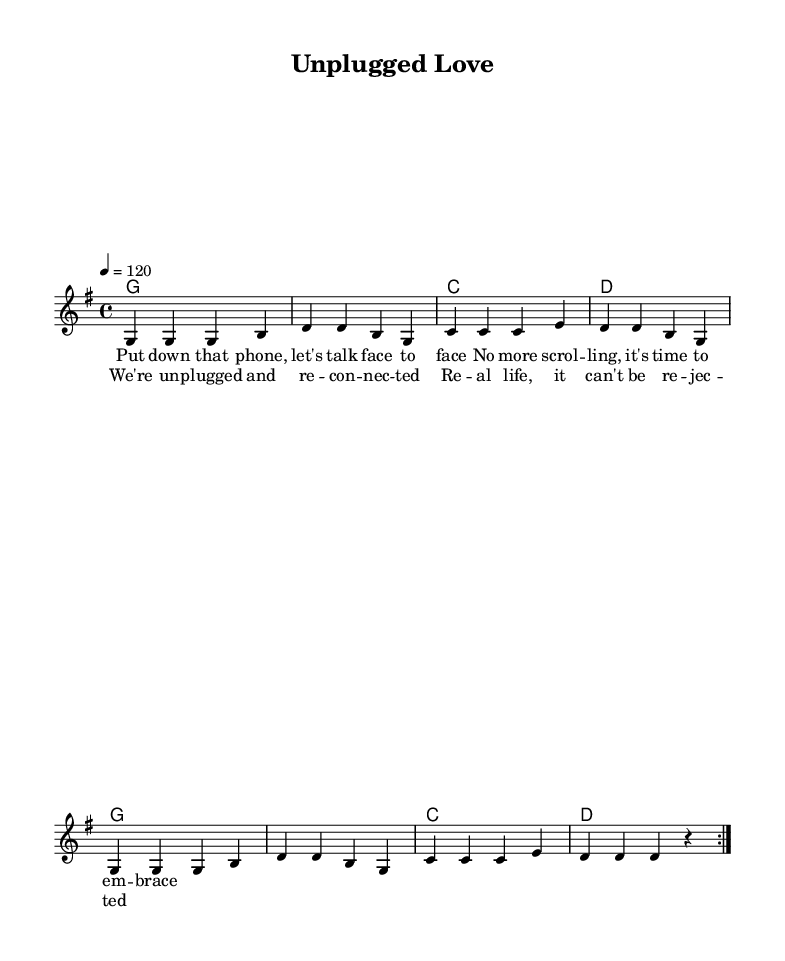What is the key signature of this music? The key signature shown is G major, indicated by one sharp (F#). This can be identified by looking at the key signature at the beginning of the staff.
Answer: G major What is the time signature of the piece? The time signature is 4/4, which can be observed near the beginning of the music and indicates that there are four beats per measure.
Answer: 4/4 What is the tempo marking given for the piece? The tempo marking is 4 = 120, meaning that a quarter note gets a tempo of 120 beats per minute. This is indicated at the beginning of the score under the global settings.
Answer: 120 How many measures are in each volta of the repeated section? Each volta of the repeated section contains 8 measures, as seen in the melody that is structured in two repeated sections of 4 measures each.
Answer: 8 What is the title of the piece? The title provided at the header of the score is "Unplugged Love." This is clearly labeled at the top of the sheet music.
Answer: Unplugged Love How many lines of lyrics are present in the verse? There are two lines of lyrics in the verse. The verse lyrics are divided into distinct lines, and one can count them directly from the lyric mode section in the score.
Answer: 2 What is the primary theme of the lyrics? The primary theme focuses on reconnecting and embracing personal interactions away from screens, as indicated in the lyrics of both the verse and chorus.
Answer: Reconnecting 